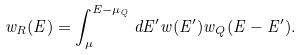<formula> <loc_0><loc_0><loc_500><loc_500>w _ { R } ( E ) = \int _ { \mu } ^ { E - \mu _ { Q } } d E ^ { \prime } w ( E ^ { \prime } ) w _ { Q } ( E - E ^ { \prime } ) .</formula> 